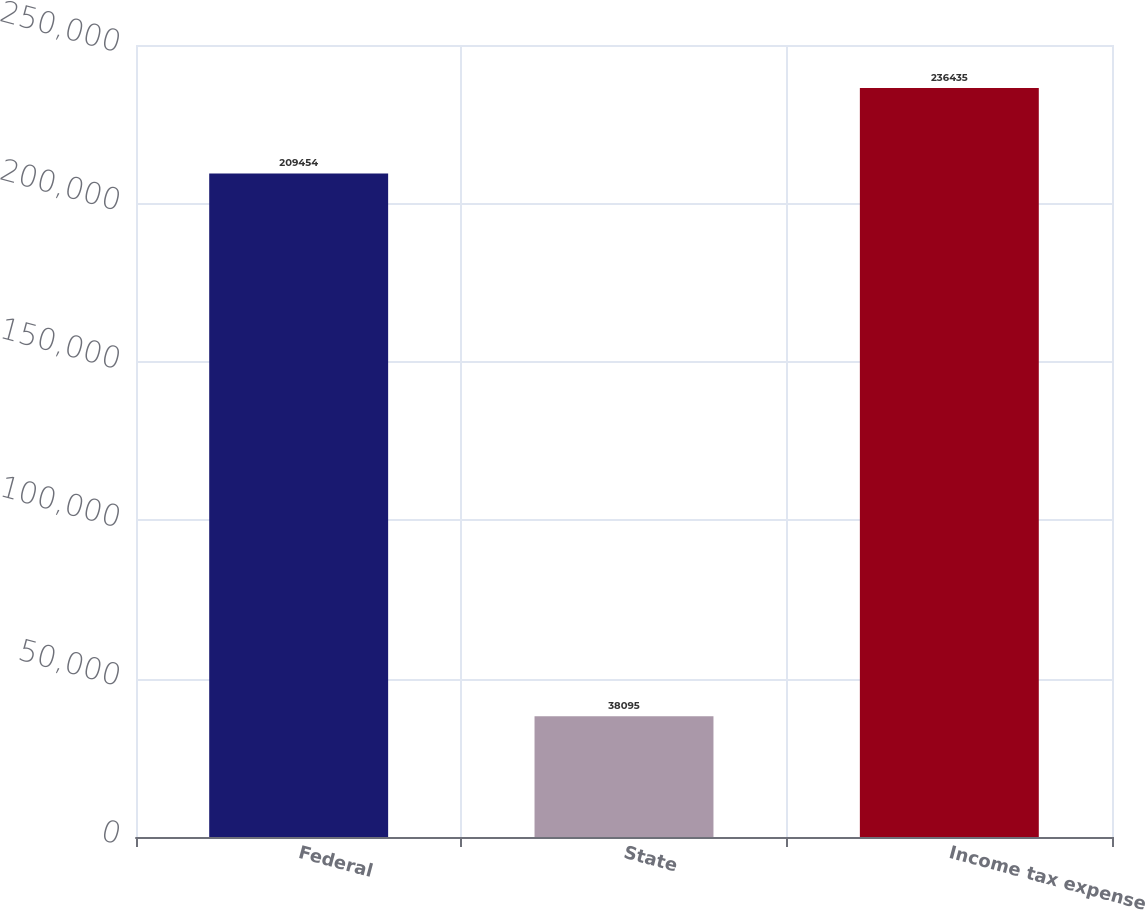Convert chart. <chart><loc_0><loc_0><loc_500><loc_500><bar_chart><fcel>Federal<fcel>State<fcel>Income tax expense<nl><fcel>209454<fcel>38095<fcel>236435<nl></chart> 